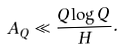Convert formula to latex. <formula><loc_0><loc_0><loc_500><loc_500>A _ { Q } \ll \frac { Q \log Q } { H } .</formula> 